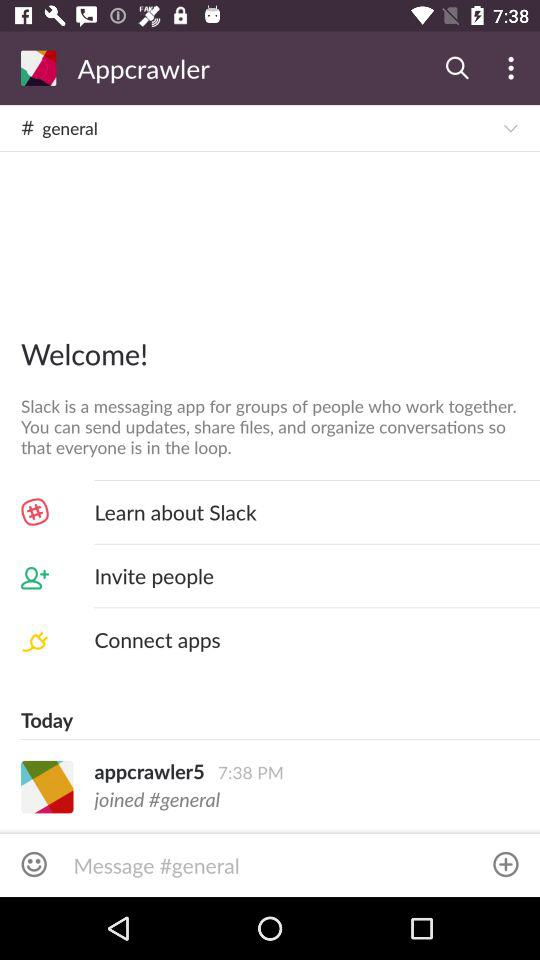What messaging application can we use to send updates and share files? You can use the "Slack" application to send updates and share files. 